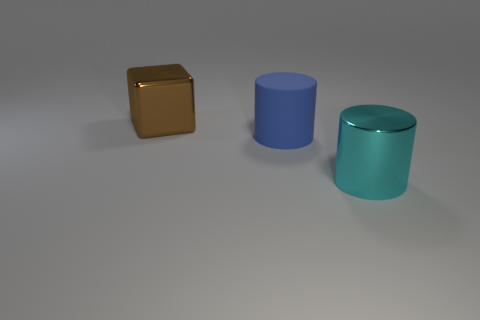Add 1 big metal cylinders. How many objects exist? 4 Subtract 0 gray spheres. How many objects are left? 3 Subtract all cubes. How many objects are left? 2 Subtract all gray cubes. Subtract all cyan balls. How many cubes are left? 1 Subtract all red balls. How many blue cylinders are left? 1 Subtract all purple balls. Subtract all brown cubes. How many objects are left? 2 Add 3 big blue objects. How many big blue objects are left? 4 Add 1 yellow blocks. How many yellow blocks exist? 1 